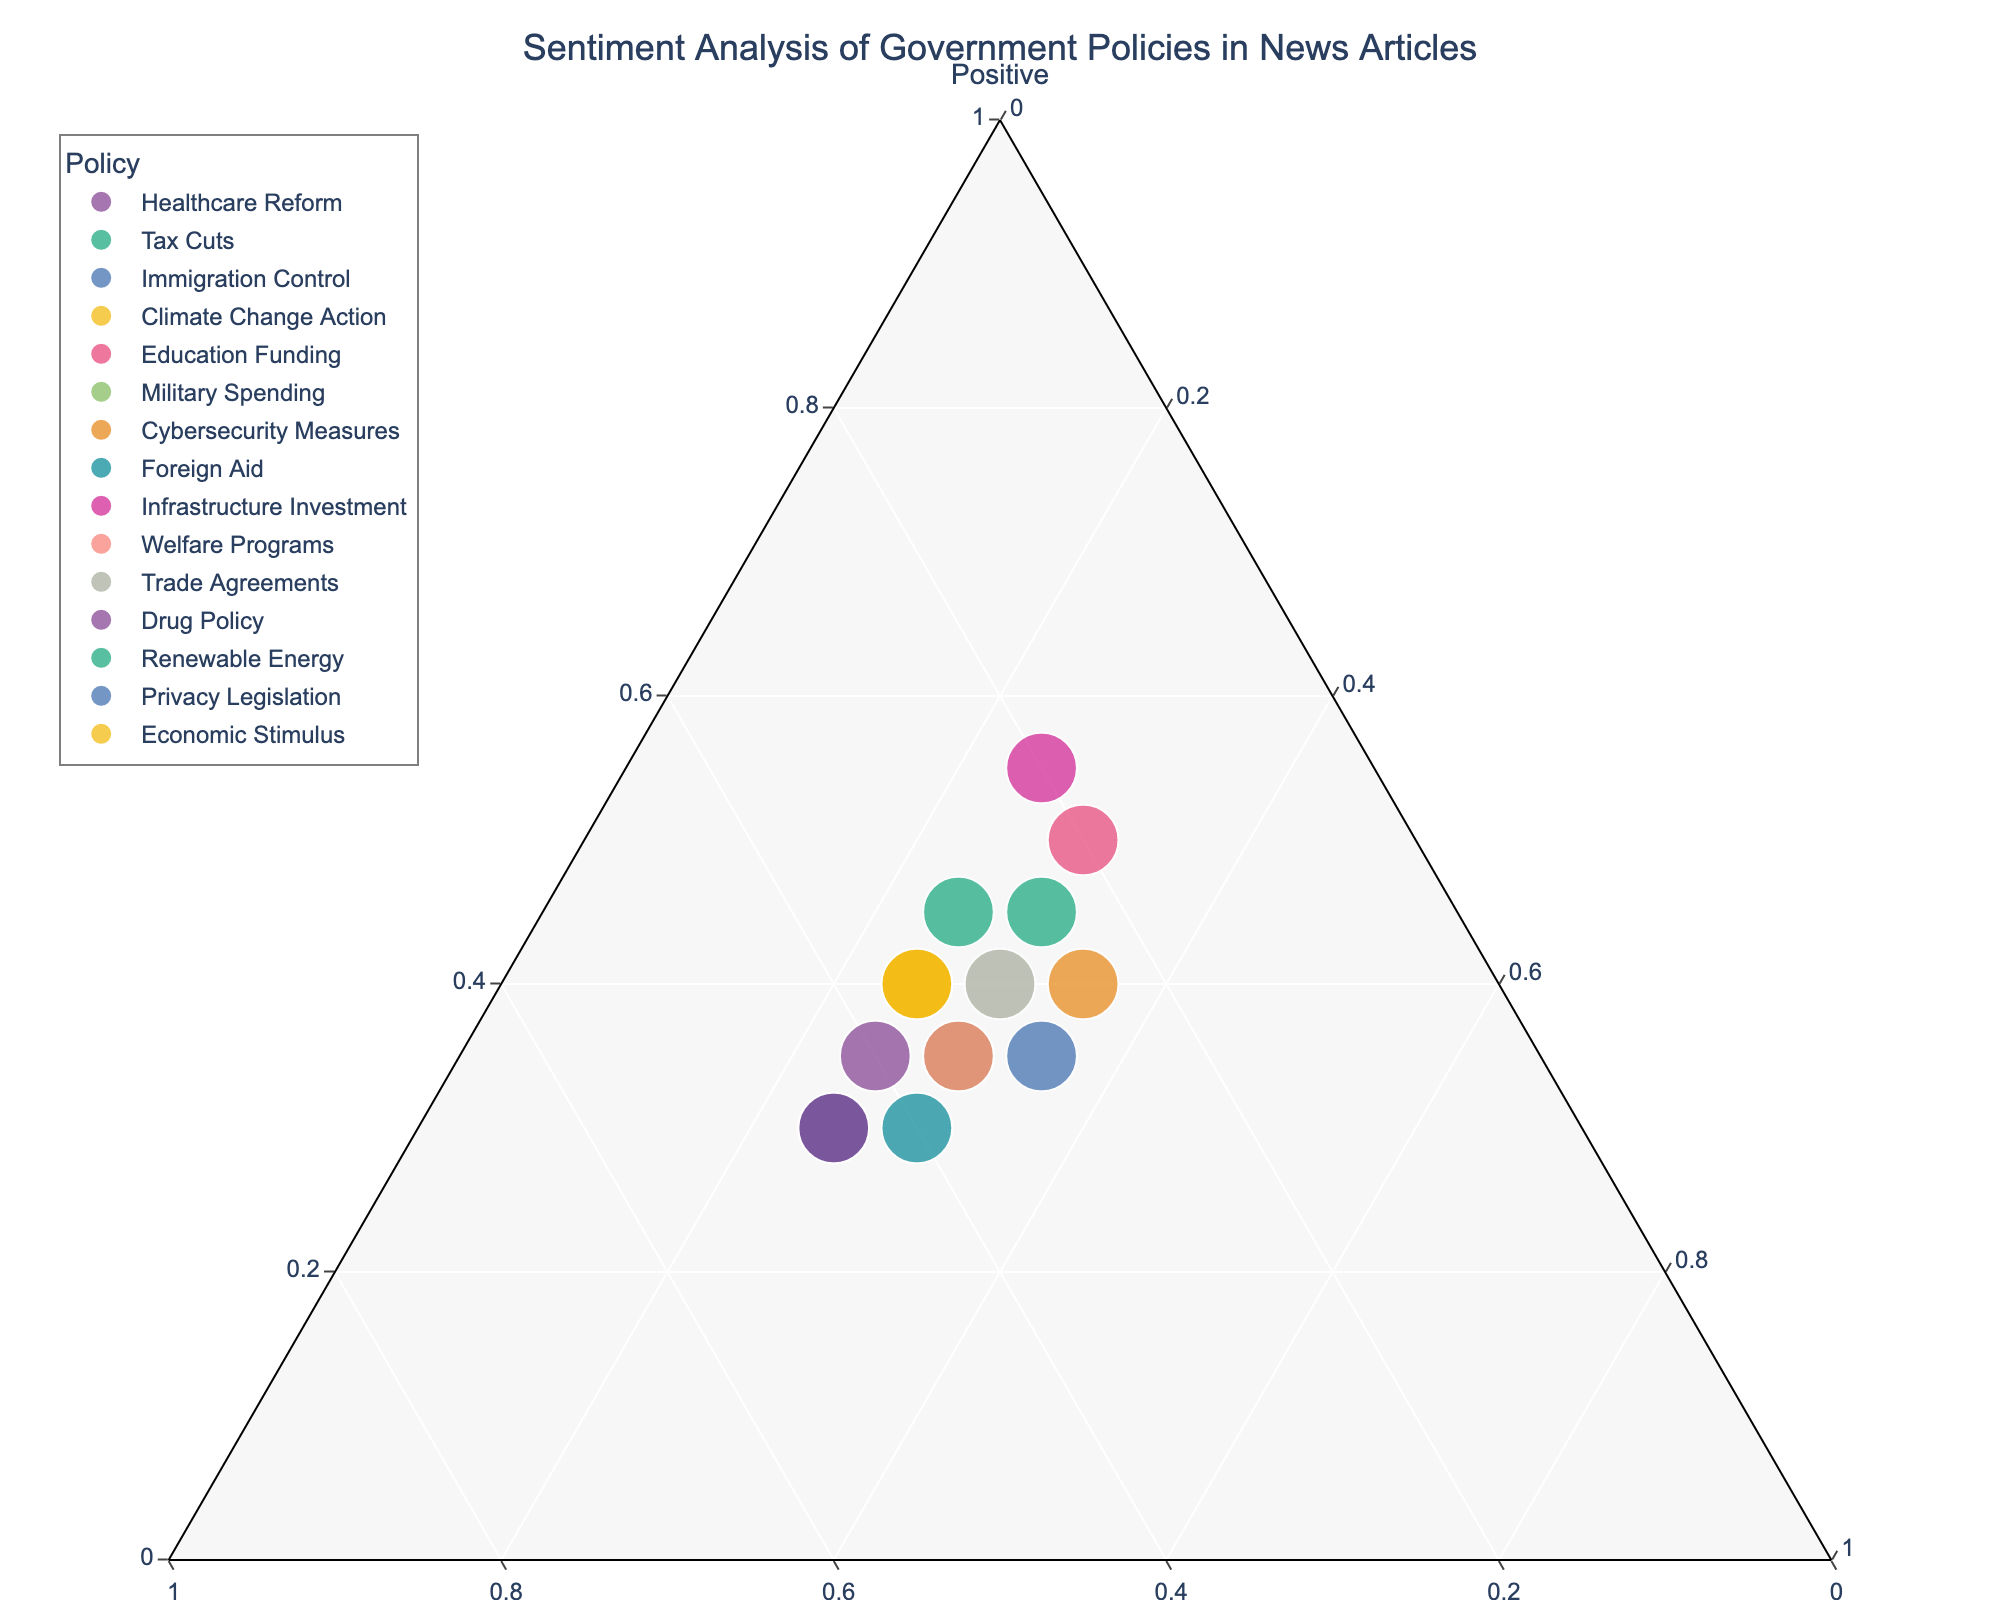What's the title of the plot? The title is typically displayed at the top of the figure. In this plot, the title reads "Sentiment Analysis of Government Policies in News Articles".
Answer: Sentiment Analysis of Government Policies in News Articles How many policies have a higher percentage of negative sentiment than positive sentiment? We compare the ratios on the ternary plot to see where the negative sentiment ratio (b axis) is greater than the positive sentiment ratio (a axis). The policies are: Immigration Control, Foreign Aid, and Drug Policy.
Answer: 3 Which policy has the highest positive sentiment ratio? We look for the policy point furthest towards the "Positive" vertex. The policy with the highest positive sentiment is "Infrastructure Investment".
Answer: Infrastructure Investment Are there any policies with equal ratios of negative and neutral sentiments? We compare if the points for any policies fall along the line where the negative and neutral ratios are equal. There are two policies: Military Spending and Welfare Programs.
Answer: Military Spending, Welfare Programs Which policy has the smallest total number of articles? The size of the points represents the total amount of news articles. The smallest point on the plot represents "Drug Policy".
Answer: Drug Policy What is the total sentiment ratio for Cybersecurity Measures? From the plot, we can see the approximate position of Cybersecurity Measures. It states the ratios: Positive: 40%, Negative: 25%, Neutral: 35%.
Answer: 40% Positive, 25% Negative, 35% Neutral Which policy is closest to having an equal distribution of positive, negative, and neutral sentiments? Equal distribution means roughly 33.3% for each sentiment. The policy closest to this point is Privacy Legislation.
Answer: Privacy Legislation Compare the positive sentiment ratio between Education Funding and Tax Cuts. Which one is greater? By locating both policies on the plot, we can see that Education Funding has a higher positive sentiment ratio (50%) compared to Tax Cuts (45%).
Answer: Education Funding What's the combined positive sentiment ratio of Tax Cuts and Renewable Energy? The positive sentiment ratio for Tax Cuts is 45% and for Renewable Energy is 45%. Summing these ratios together gives 45% + 45% = 90%.
Answer: 90% Which policy has the highest neutral sentiment ratio? We identify which policy point is closest to the "Neutral" vertex. In this case, it is Cybersecurity Measures.
Answer: Cybersecurity Measures 